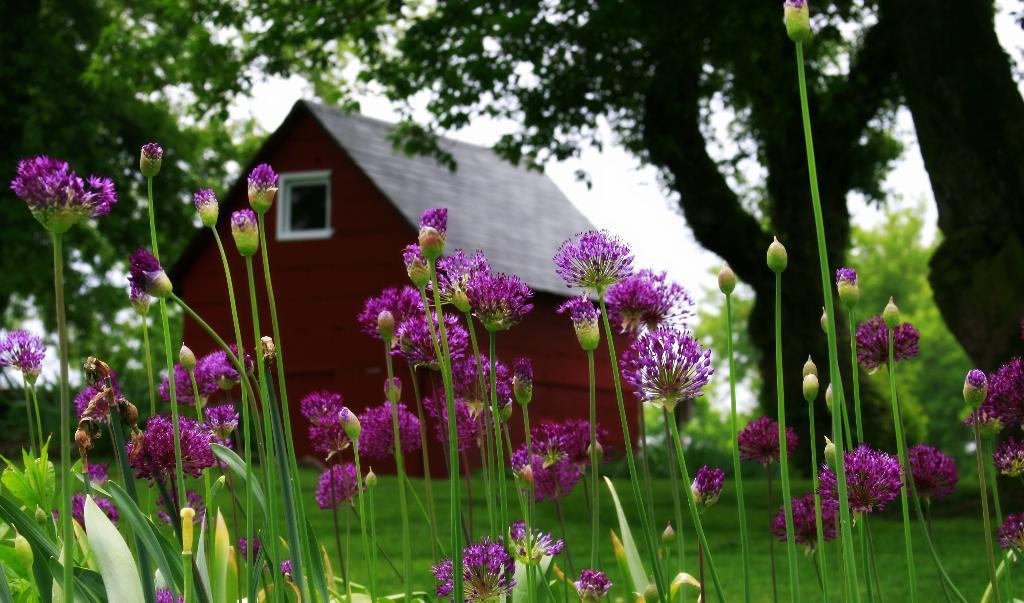How would you summarize this image in a sentence or two? In the foreground of this picture, there are violet color flowers to the plants and we can also see buds to it. In the background, there is a house, trees and the sky. 